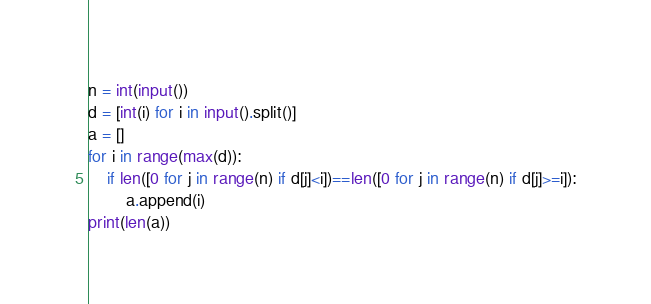Convert code to text. <code><loc_0><loc_0><loc_500><loc_500><_Python_>n = int(input())
d = [int(i) for i in input().split()]
a = []
for i in range(max(d)):
    if len([0 for j in range(n) if d[j]<i])==len([0 for j in range(n) if d[j]>=i]):
        a.append(i)
print(len(a))</code> 